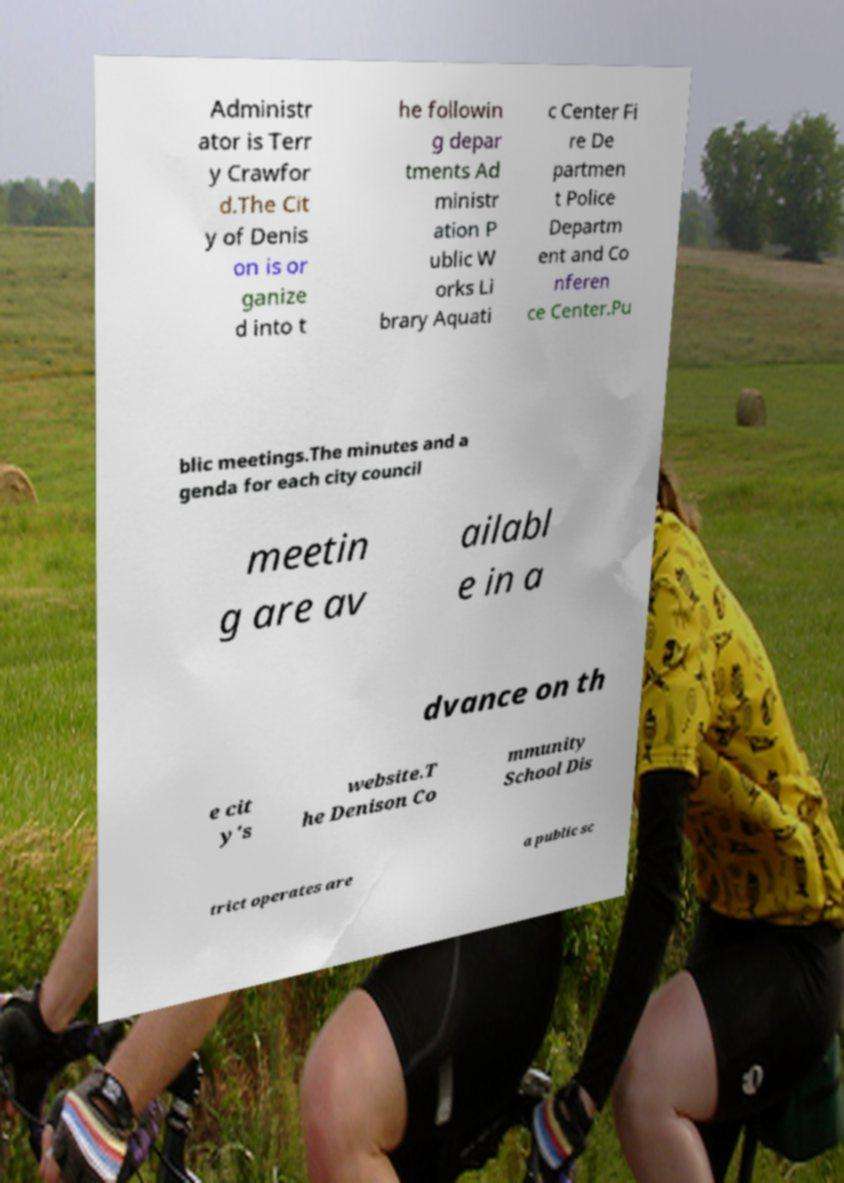Can you read and provide the text displayed in the image?This photo seems to have some interesting text. Can you extract and type it out for me? Administr ator is Terr y Crawfor d.The Cit y of Denis on is or ganize d into t he followin g depar tments Ad ministr ation P ublic W orks Li brary Aquati c Center Fi re De partmen t Police Departm ent and Co nferen ce Center.Pu blic meetings.The minutes and a genda for each city council meetin g are av ailabl e in a dvance on th e cit y's website.T he Denison Co mmunity School Dis trict operates are a public sc 